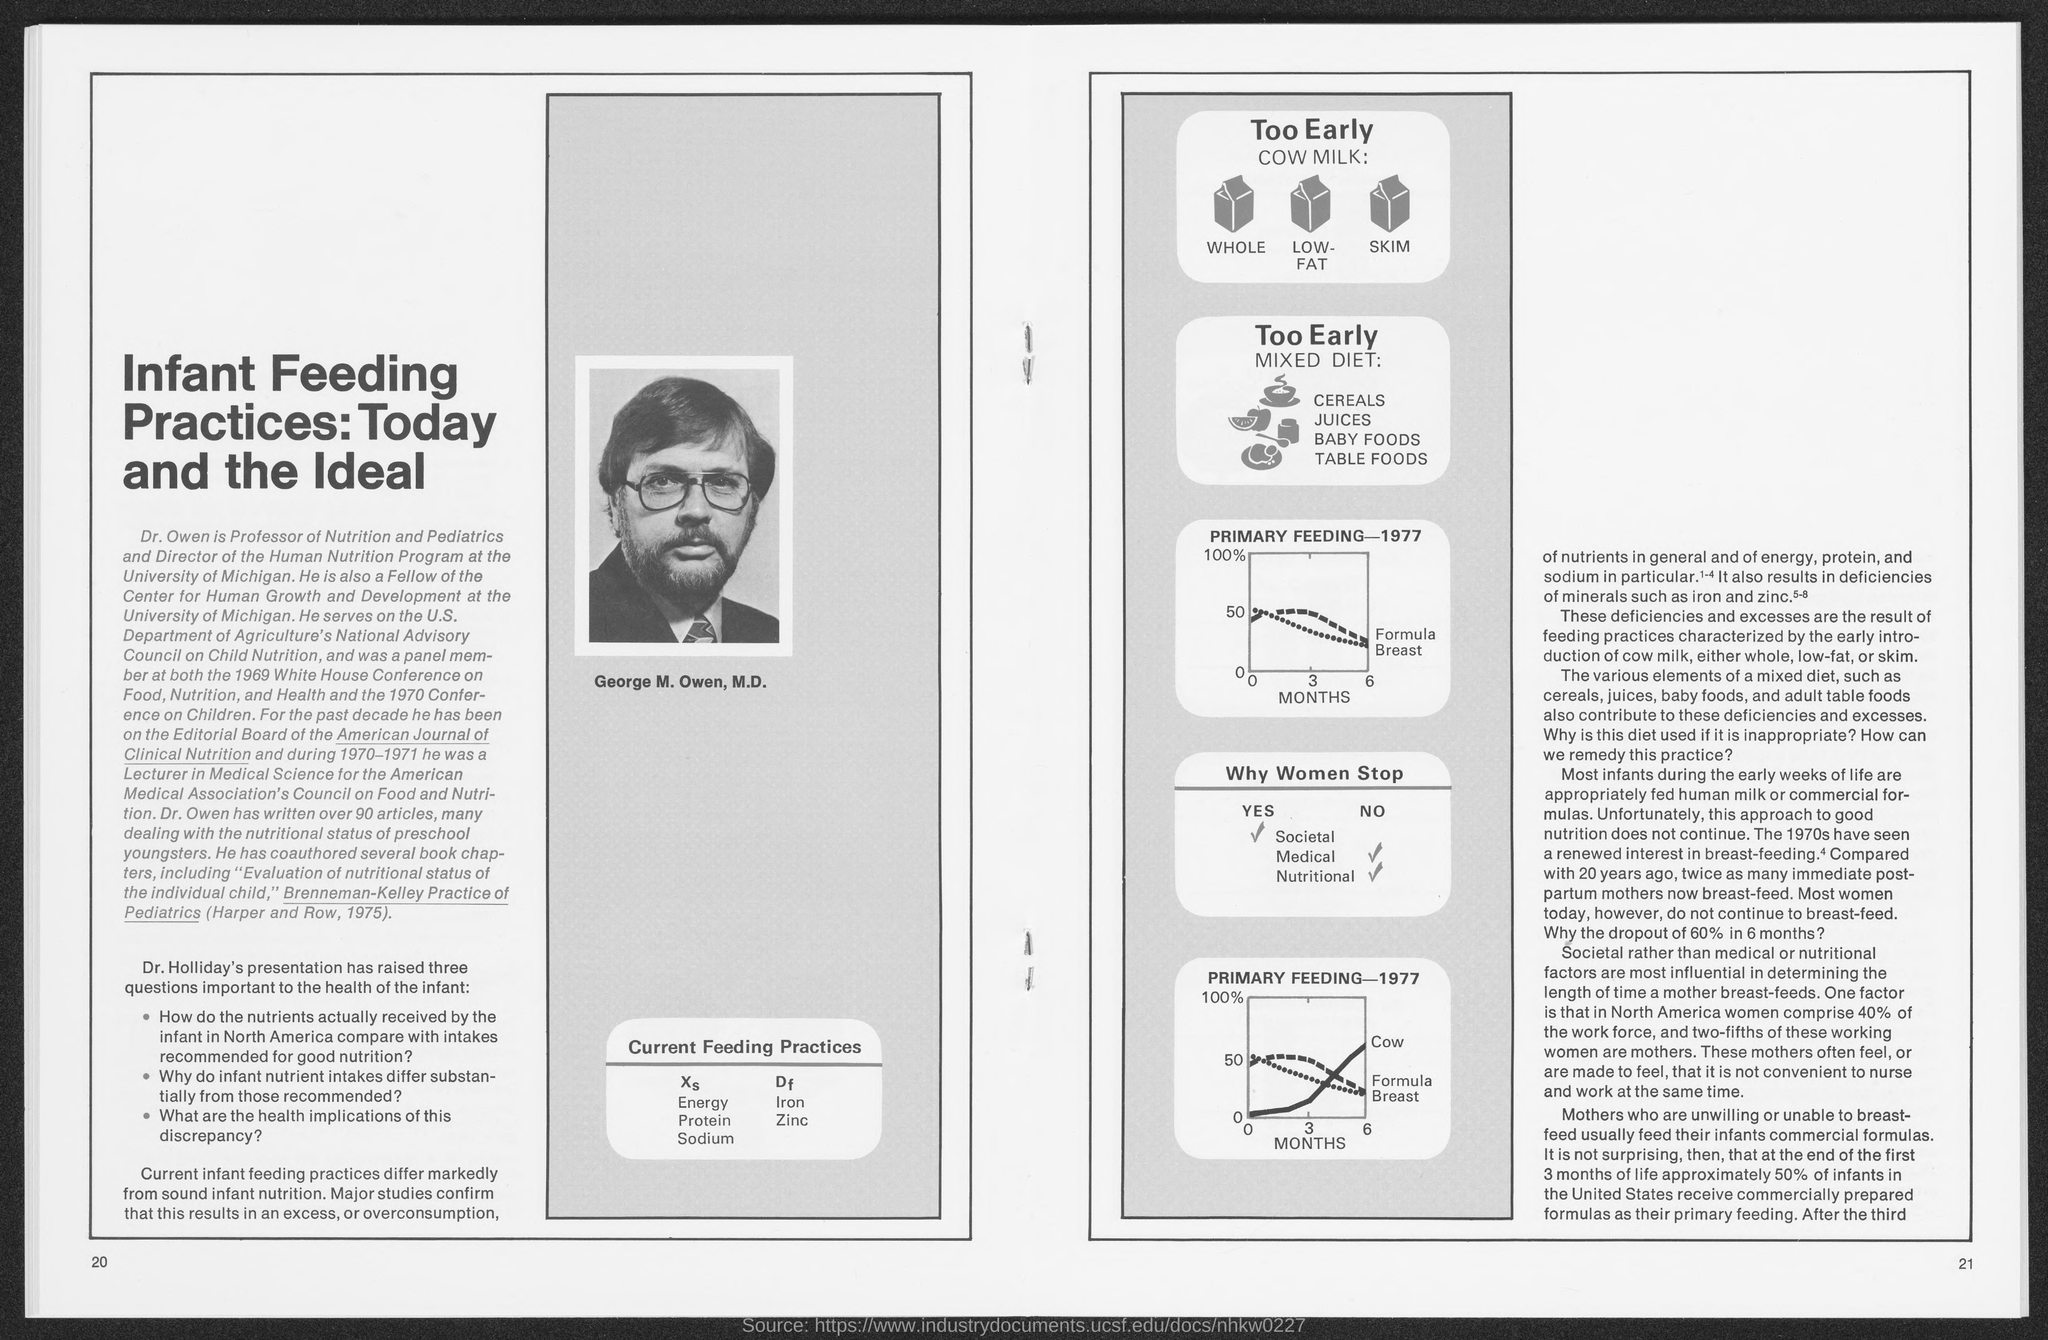Name the University where Dr.Owen acts as a Professor and Director?
Your response must be concise. University of Michigan. How many articles are written by Dr.Owen?
Ensure brevity in your answer.  90. Which year renowned interest in breast feeding was shown?
Your response must be concise. 1970s. What was the role of Dr.Owen in The Human Nutrition Program of University of Michigan?
Give a very brief answer. Director. What was the role of Dr.Owen in the Nutrition and Pediatrics in the University of Michigan?
Offer a very short reply. Professor. What are the infants fed during their early weeks of life?
Give a very brief answer. Human milk or commercial formulas. What was the role played by Dr.Owen in the Center for Human Growth  and Development?
Offer a terse response. Fellow. 